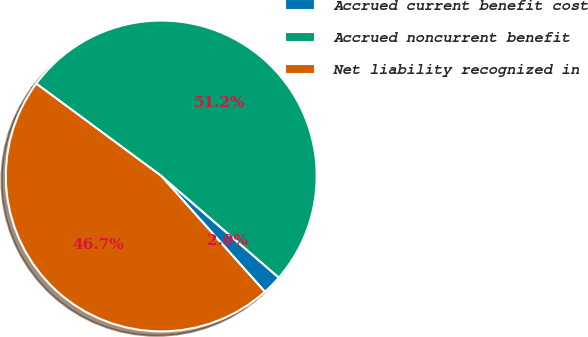Convert chart to OTSL. <chart><loc_0><loc_0><loc_500><loc_500><pie_chart><fcel>Accrued current benefit cost<fcel>Accrued noncurrent benefit<fcel>Net liability recognized in<nl><fcel>2.04%<fcel>51.22%<fcel>46.74%<nl></chart> 